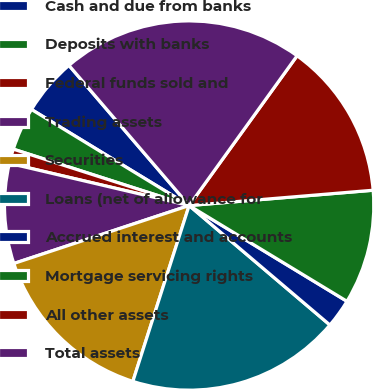Convert chart. <chart><loc_0><loc_0><loc_500><loc_500><pie_chart><fcel>Cash and due from banks<fcel>Deposits with banks<fcel>Federal funds sold and<fcel>Trading assets<fcel>Securities<fcel>Loans (net of allowance for<fcel>Accrued interest and accounts<fcel>Mortgage servicing rights<fcel>All other assets<fcel>Total assets<nl><fcel>5.01%<fcel>3.77%<fcel>1.27%<fcel>8.75%<fcel>14.99%<fcel>18.73%<fcel>2.52%<fcel>10.0%<fcel>13.74%<fcel>21.22%<nl></chart> 